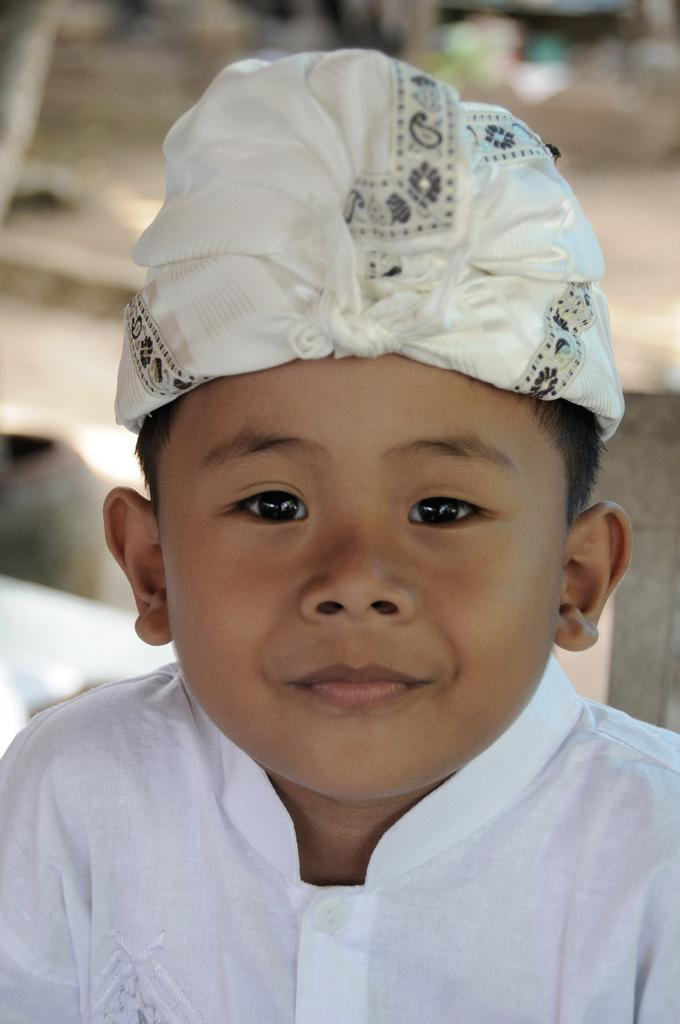What is the main subject of the image? There is a kid in the center of the image. What direction is the crib facing in the image? There is no crib present in the image. How does the kid use the brake in the image? There is no brake present in the image, and the kid is not shown using any such device. 